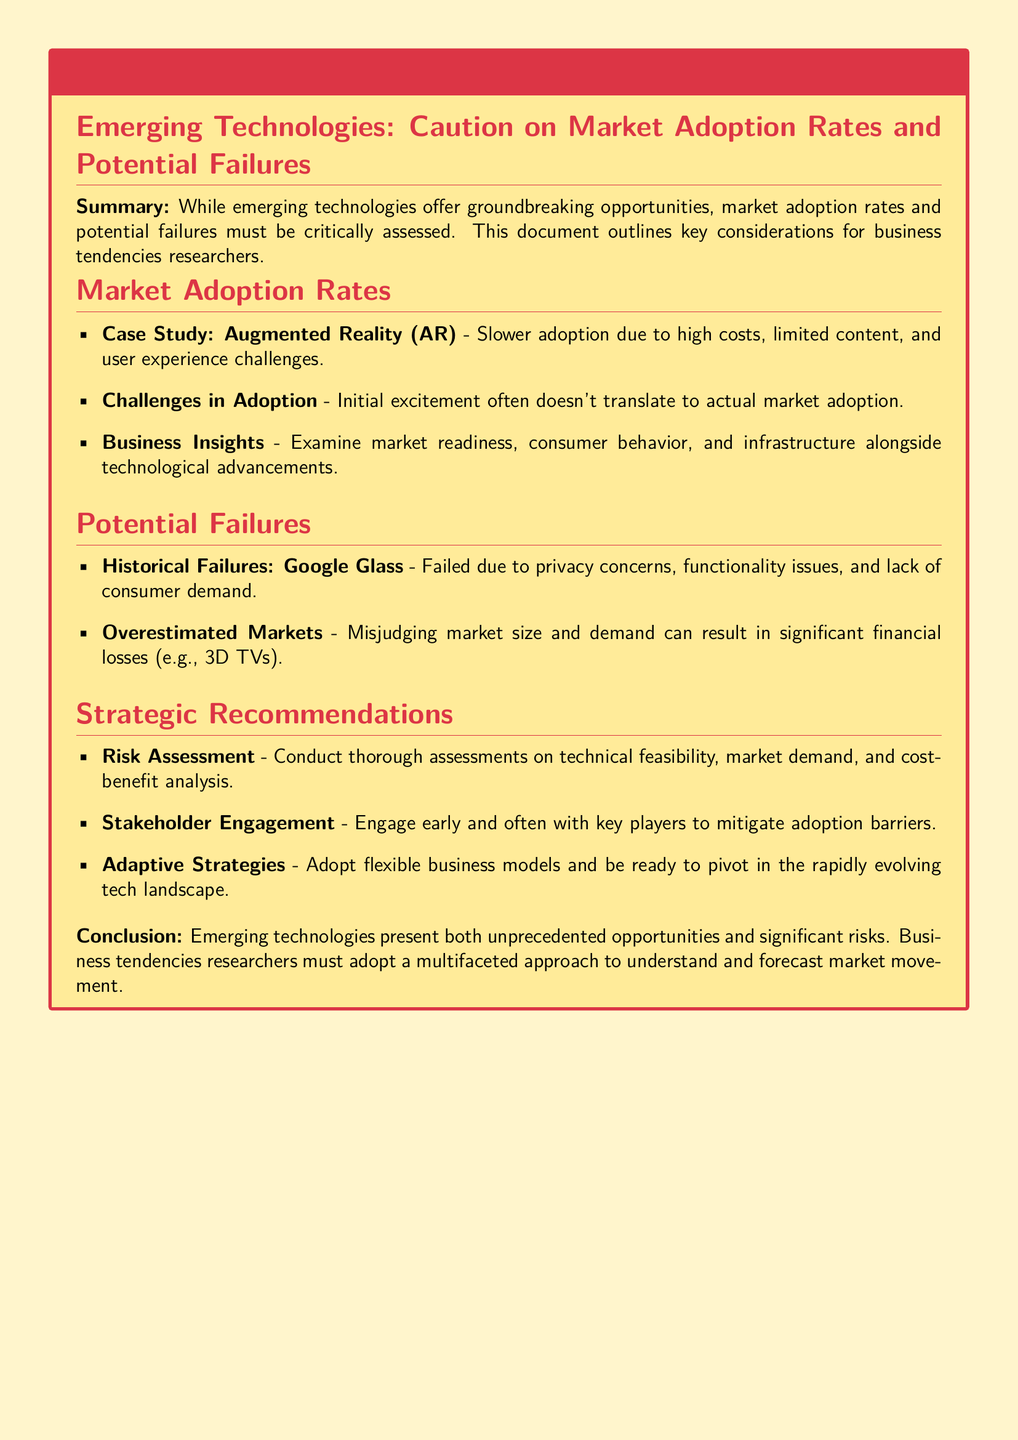What is the main caution advised in the document? The document advises caution on market adoption rates and potential failures.
Answer: market adoption rates and potential failures What example does the document provide for slow adoption? The case study of Augmented Reality highlights slower adoption due to specific challenges.
Answer: Augmented Reality (AR) Which historical failure is mentioned as an example? Google Glass is cited as a historical failure due to various issues.
Answer: Google Glass What is a recommended strategy for mitigating adoption barriers? Engaging with stakeholders is suggested as a key strategy.
Answer: Stakeholder Engagement What technological advancement challenge is highlighted in the document? It mentions that initial excitement does not always lead to market adoption.
Answer: initial excitement How does the document recommend assessing risks? It suggests conducting a thorough risk assessment including several factors.
Answer: Technical feasibility, market demand, and cost-benefit analysis Which product is noted for being overestimated in market demand? The document states that 3D TVs had misjudged market size and demand.
Answer: 3D TVs What section discusses challenges in adoption? The section titled "Market Adoption Rates" addresses challenges related to adoption.
Answer: Market Adoption Rates What type of approach should researchers adopt according to the conclusion? The conclusion emphasizes a multifaceted approach for understanding market movement.
Answer: multifaceted approach 